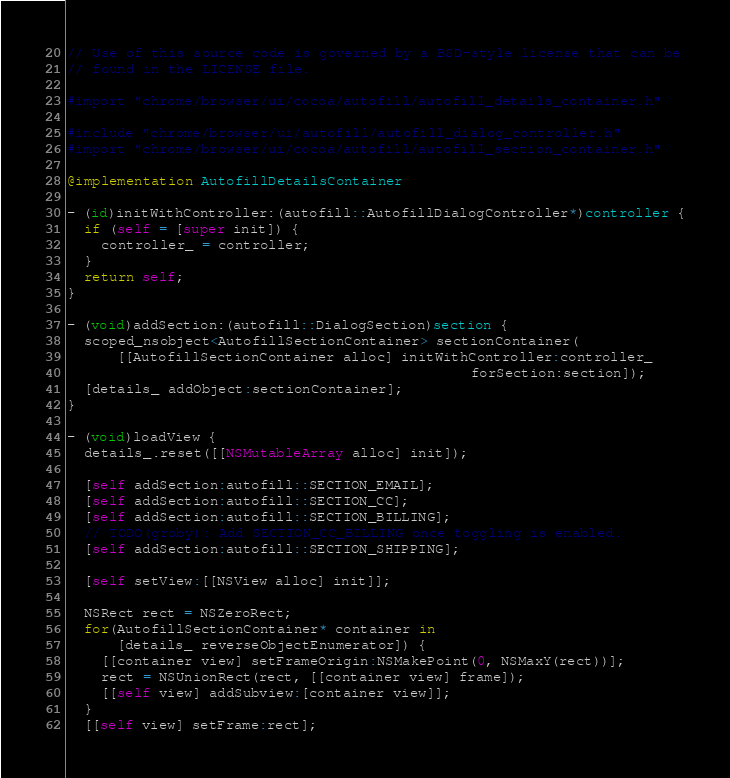Convert code to text. <code><loc_0><loc_0><loc_500><loc_500><_ObjectiveC_>// Use of this source code is governed by a BSD-style license that can be
// found in the LICENSE file.

#import "chrome/browser/ui/cocoa/autofill/autofill_details_container.h"

#include "chrome/browser/ui/autofill/autofill_dialog_controller.h"
#import "chrome/browser/ui/cocoa/autofill/autofill_section_container.h"

@implementation AutofillDetailsContainer

- (id)initWithController:(autofill::AutofillDialogController*)controller {
  if (self = [super init]) {
    controller_ = controller;
  }
  return self;
}

- (void)addSection:(autofill::DialogSection)section {
  scoped_nsobject<AutofillSectionContainer> sectionContainer(
      [[AutofillSectionContainer alloc] initWithController:controller_
                                                forSection:section]);
  [details_ addObject:sectionContainer];
}

- (void)loadView {
  details_.reset([[NSMutableArray alloc] init]);

  [self addSection:autofill::SECTION_EMAIL];
  [self addSection:autofill::SECTION_CC];
  [self addSection:autofill::SECTION_BILLING];
  // TODO(groby): Add SECTION_CC_BILLING once toggling is enabled.
  [self addSection:autofill::SECTION_SHIPPING];

  [self setView:[[NSView alloc] init]];

  NSRect rect = NSZeroRect;
  for(AutofillSectionContainer* container in
      [details_ reverseObjectEnumerator]) {
    [[container view] setFrameOrigin:NSMakePoint(0, NSMaxY(rect))];
    rect = NSUnionRect(rect, [[container view] frame]);
    [[self view] addSubview:[container view]];
  }
  [[self view] setFrame:rect];</code> 